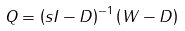<formula> <loc_0><loc_0><loc_500><loc_500>Q = \left ( s I - D \right ) ^ { - 1 } \left ( W - D \right )</formula> 